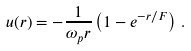Convert formula to latex. <formula><loc_0><loc_0><loc_500><loc_500>u ( r ) = - \frac { 1 } { \omega _ { p } r } \left ( 1 - e ^ { - r / F } \right ) \, .</formula> 